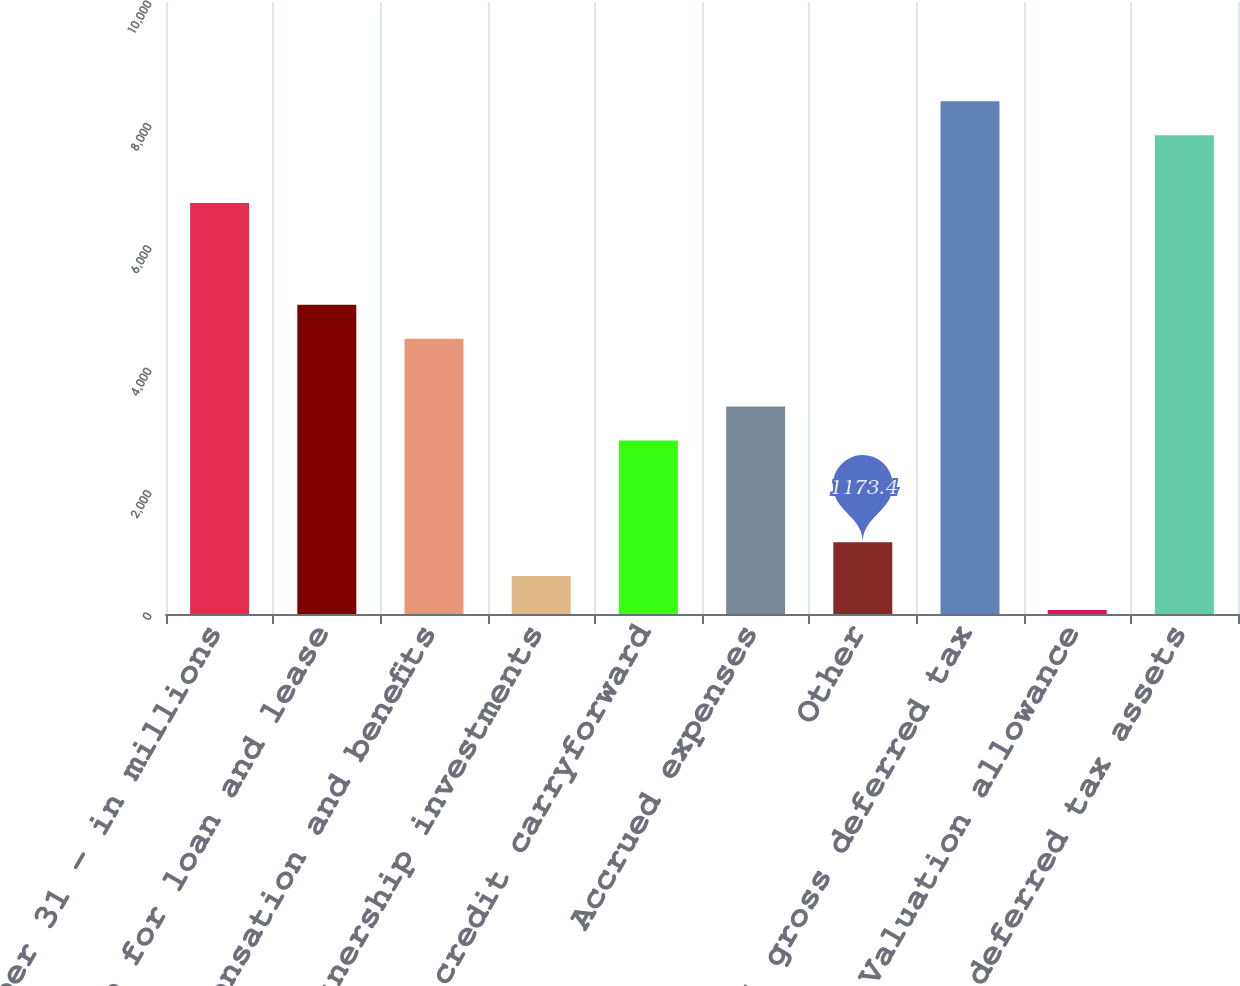<chart> <loc_0><loc_0><loc_500><loc_500><bar_chart><fcel>December 31 - in millions<fcel>Allowance for loan and lease<fcel>Compensation and benefits<fcel>Partnership investments<fcel>Loss and credit carryforward<fcel>Accrued expenses<fcel>Other<fcel>Total gross deferred tax<fcel>Valuation allowance<fcel>Total deferred tax assets<nl><fcel>6715.4<fcel>5052.8<fcel>4498.6<fcel>619.2<fcel>2836<fcel>3390.2<fcel>1173.4<fcel>8378<fcel>65<fcel>7823.8<nl></chart> 